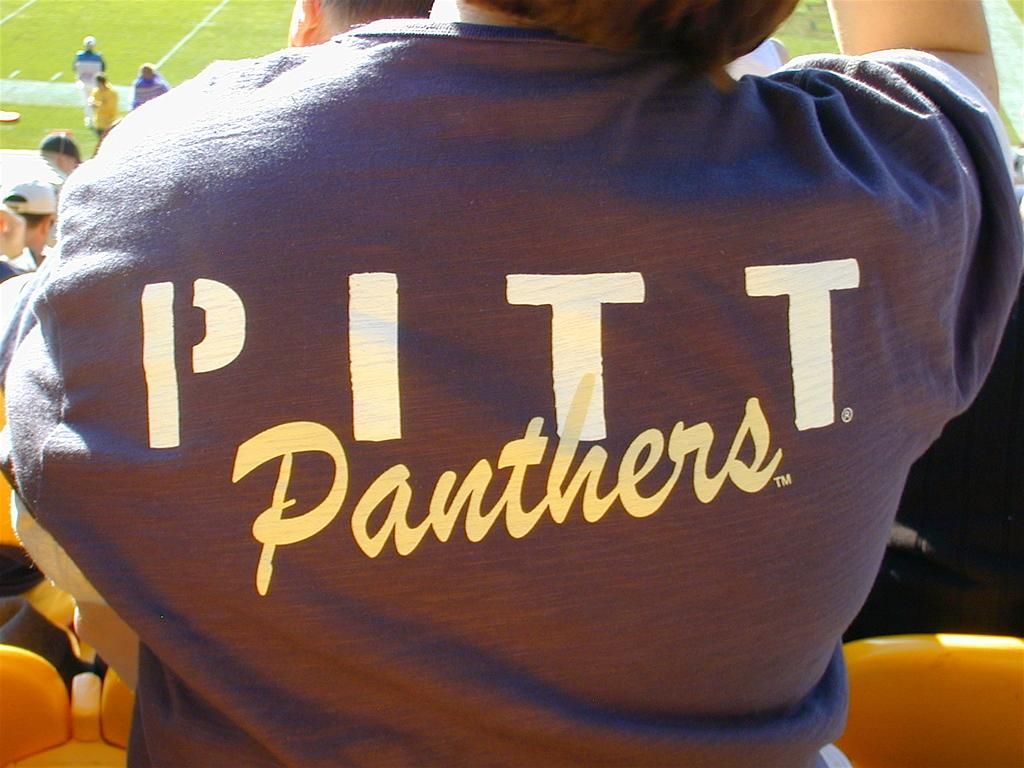Provide a one-sentence caption for the provided image. Pitt Panthers written on the back of a dark t-shirt. 